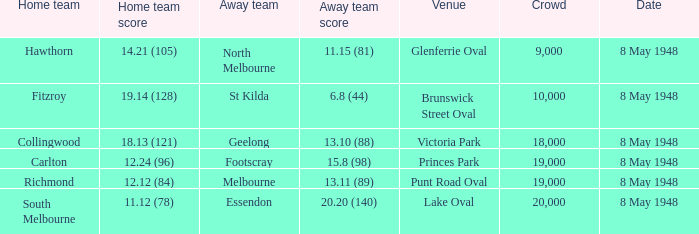Which away team played the home team when they scored 14.21 (105)? North Melbourne. 